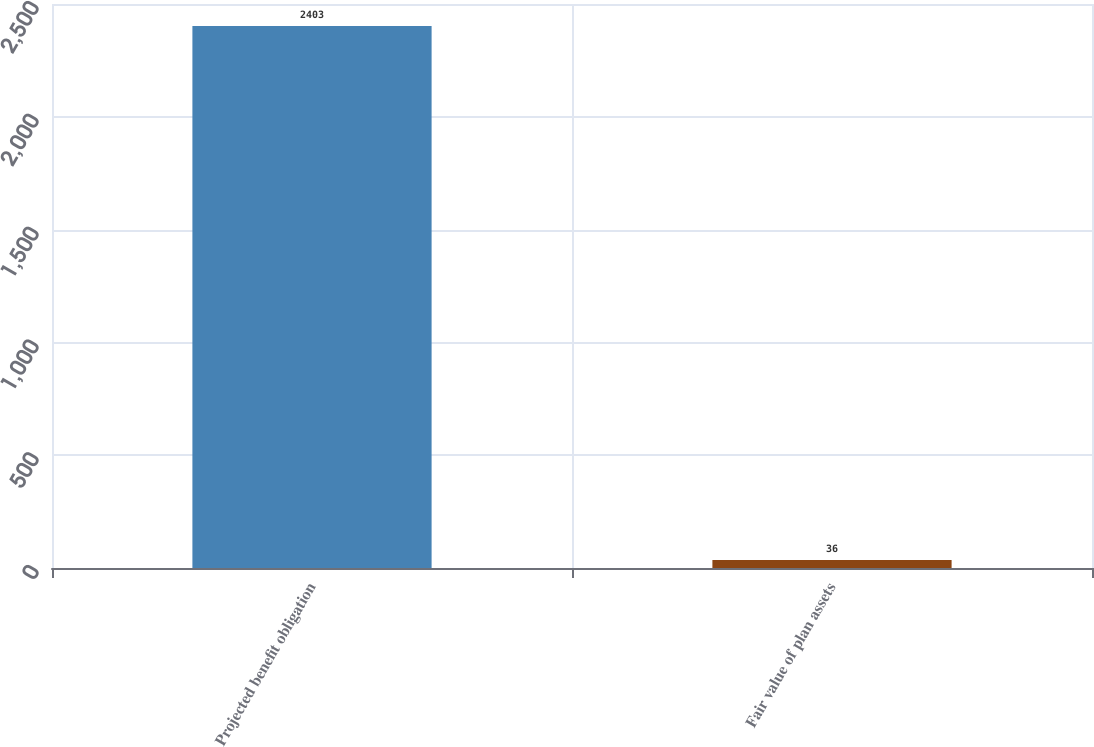<chart> <loc_0><loc_0><loc_500><loc_500><bar_chart><fcel>Projected benefit obligation<fcel>Fair value of plan assets<nl><fcel>2403<fcel>36<nl></chart> 